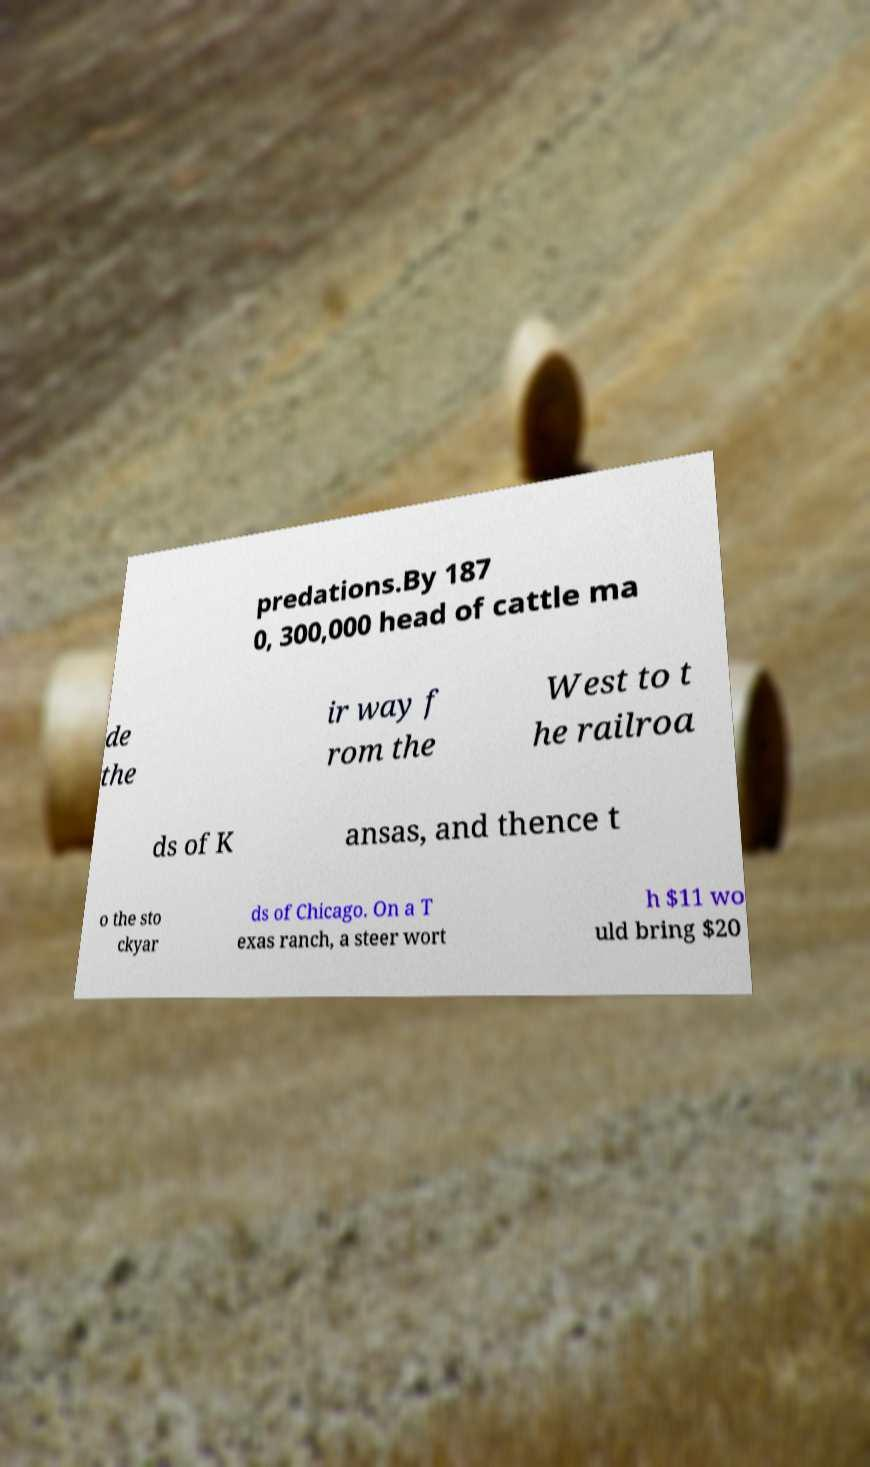For documentation purposes, I need the text within this image transcribed. Could you provide that? predations.By 187 0, 300,000 head of cattle ma de the ir way f rom the West to t he railroa ds of K ansas, and thence t o the sto ckyar ds of Chicago. On a T exas ranch, a steer wort h $11 wo uld bring $20 